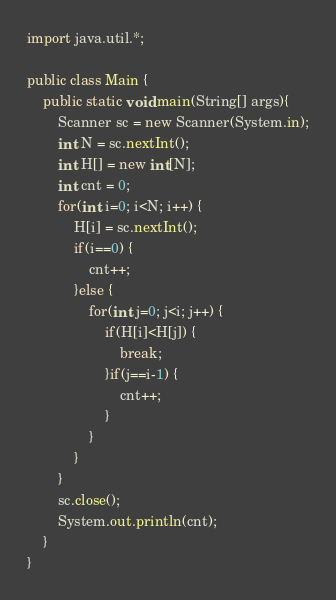<code> <loc_0><loc_0><loc_500><loc_500><_Java_>import java.util.*;

public class Main {
    public static void main(String[] args){
        Scanner sc = new Scanner(System.in);
        int N = sc.nextInt();
        int H[] = new int[N];
        int cnt = 0;
        for(int i=0; i<N; i++) {
        	H[i] = sc.nextInt();
        	if(i==0) {
        		cnt++;
        	}else {
        		for(int j=0; j<i; j++) {
        			if(H[i]<H[j]) {
        				break;
        			}if(j==i-1) {
        				cnt++;
        			}
        		}
        	}
        }
        sc.close();
        System.out.println(cnt);      
    }
}</code> 